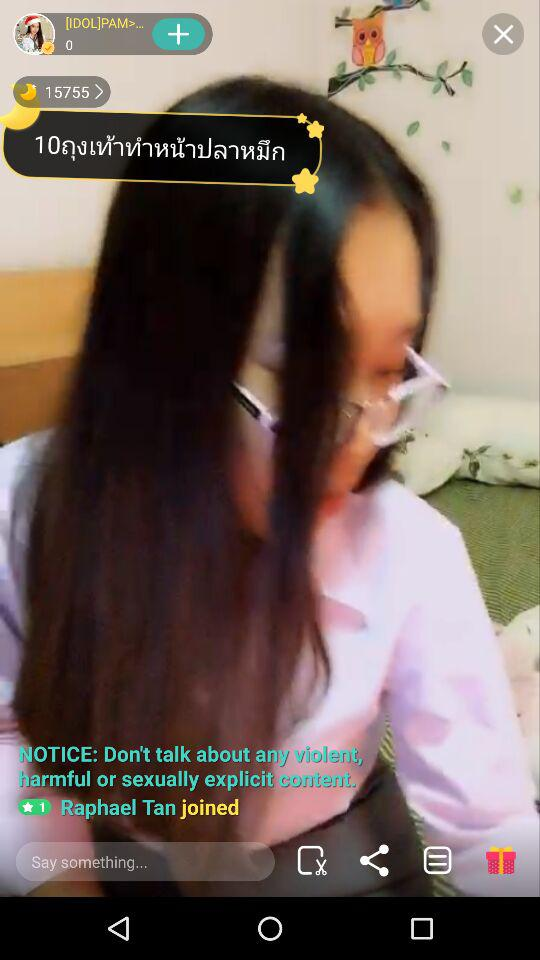What is the name of the user who joined? The name of the user who joined is Raphael Tan. 